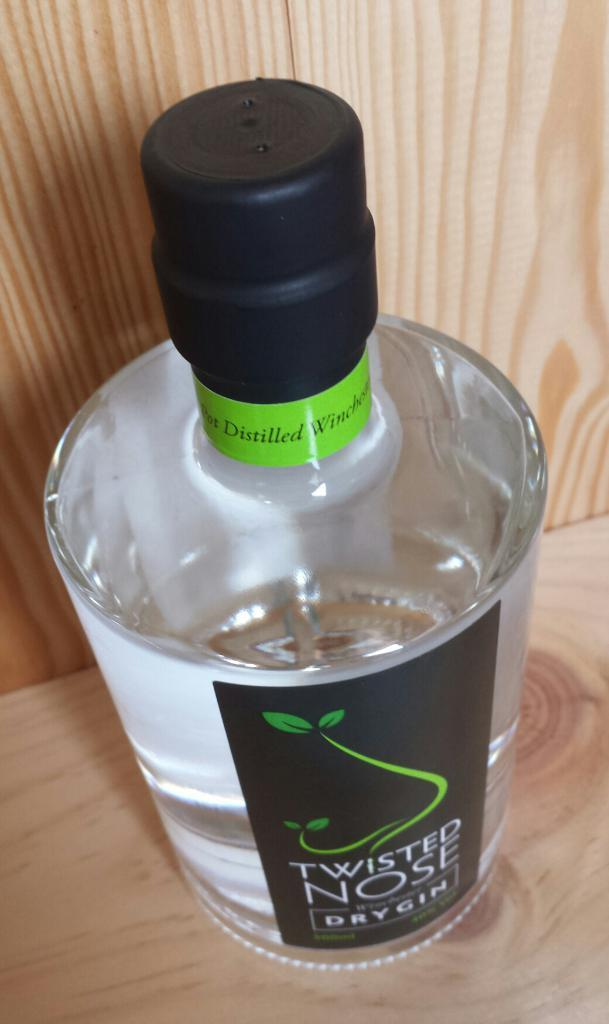Provide a one-sentence caption for the provided image. A bottle of Twisted Nose dry gin on a wooden shelf. 